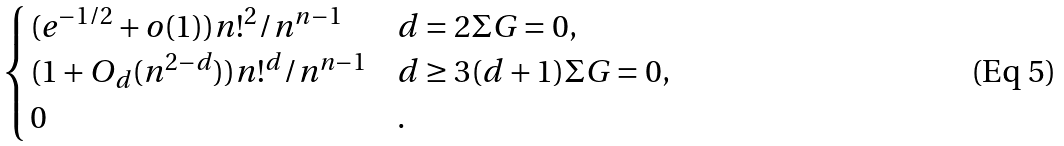<formula> <loc_0><loc_0><loc_500><loc_500>\begin{cases} ( e ^ { - 1 / 2 } + o ( 1 ) ) n ! ^ { 2 } / n ^ { n - 1 } & d = 2 \Sigma G = 0 , \\ ( 1 + O _ { d } ( n ^ { 2 - d } ) ) n ! ^ { d } / n ^ { n - 1 } & d \geq 3 ( d + 1 ) \Sigma G = 0 , \\ 0 & . \end{cases}</formula> 